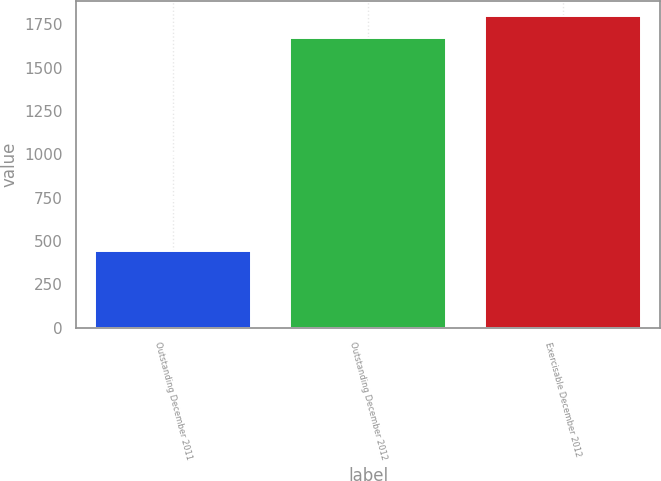Convert chart to OTSL. <chart><loc_0><loc_0><loc_500><loc_500><bar_chart><fcel>Outstanding December 2011<fcel>Outstanding December 2012<fcel>Exercisable December 2012<nl><fcel>444<fcel>1672<fcel>1794.8<nl></chart> 